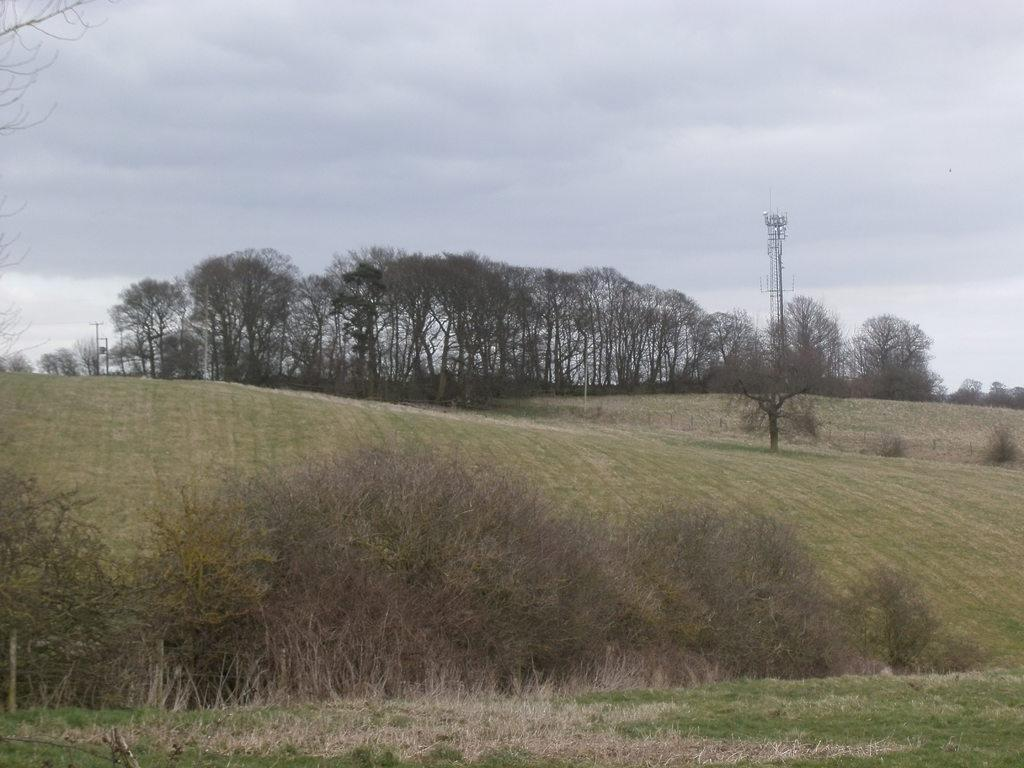What type of vegetation can be seen on the mountain in the image? There is grass on the mountain in the image. What is located behind the mountain? There are trees behind the mountain. What man-made structures are visible in the image? Electrical poles are visible in the image. What type of leather can be seen on the mountain in the image? There is no leather present on the mountain in the image. Can you see a footprint in the grass on the mountain? There is no mention of footprints in the grass in the image. Are there any pickles growing on the trees behind the mountain? There is no mention of pickles in the image; the trees are not described in detail. 